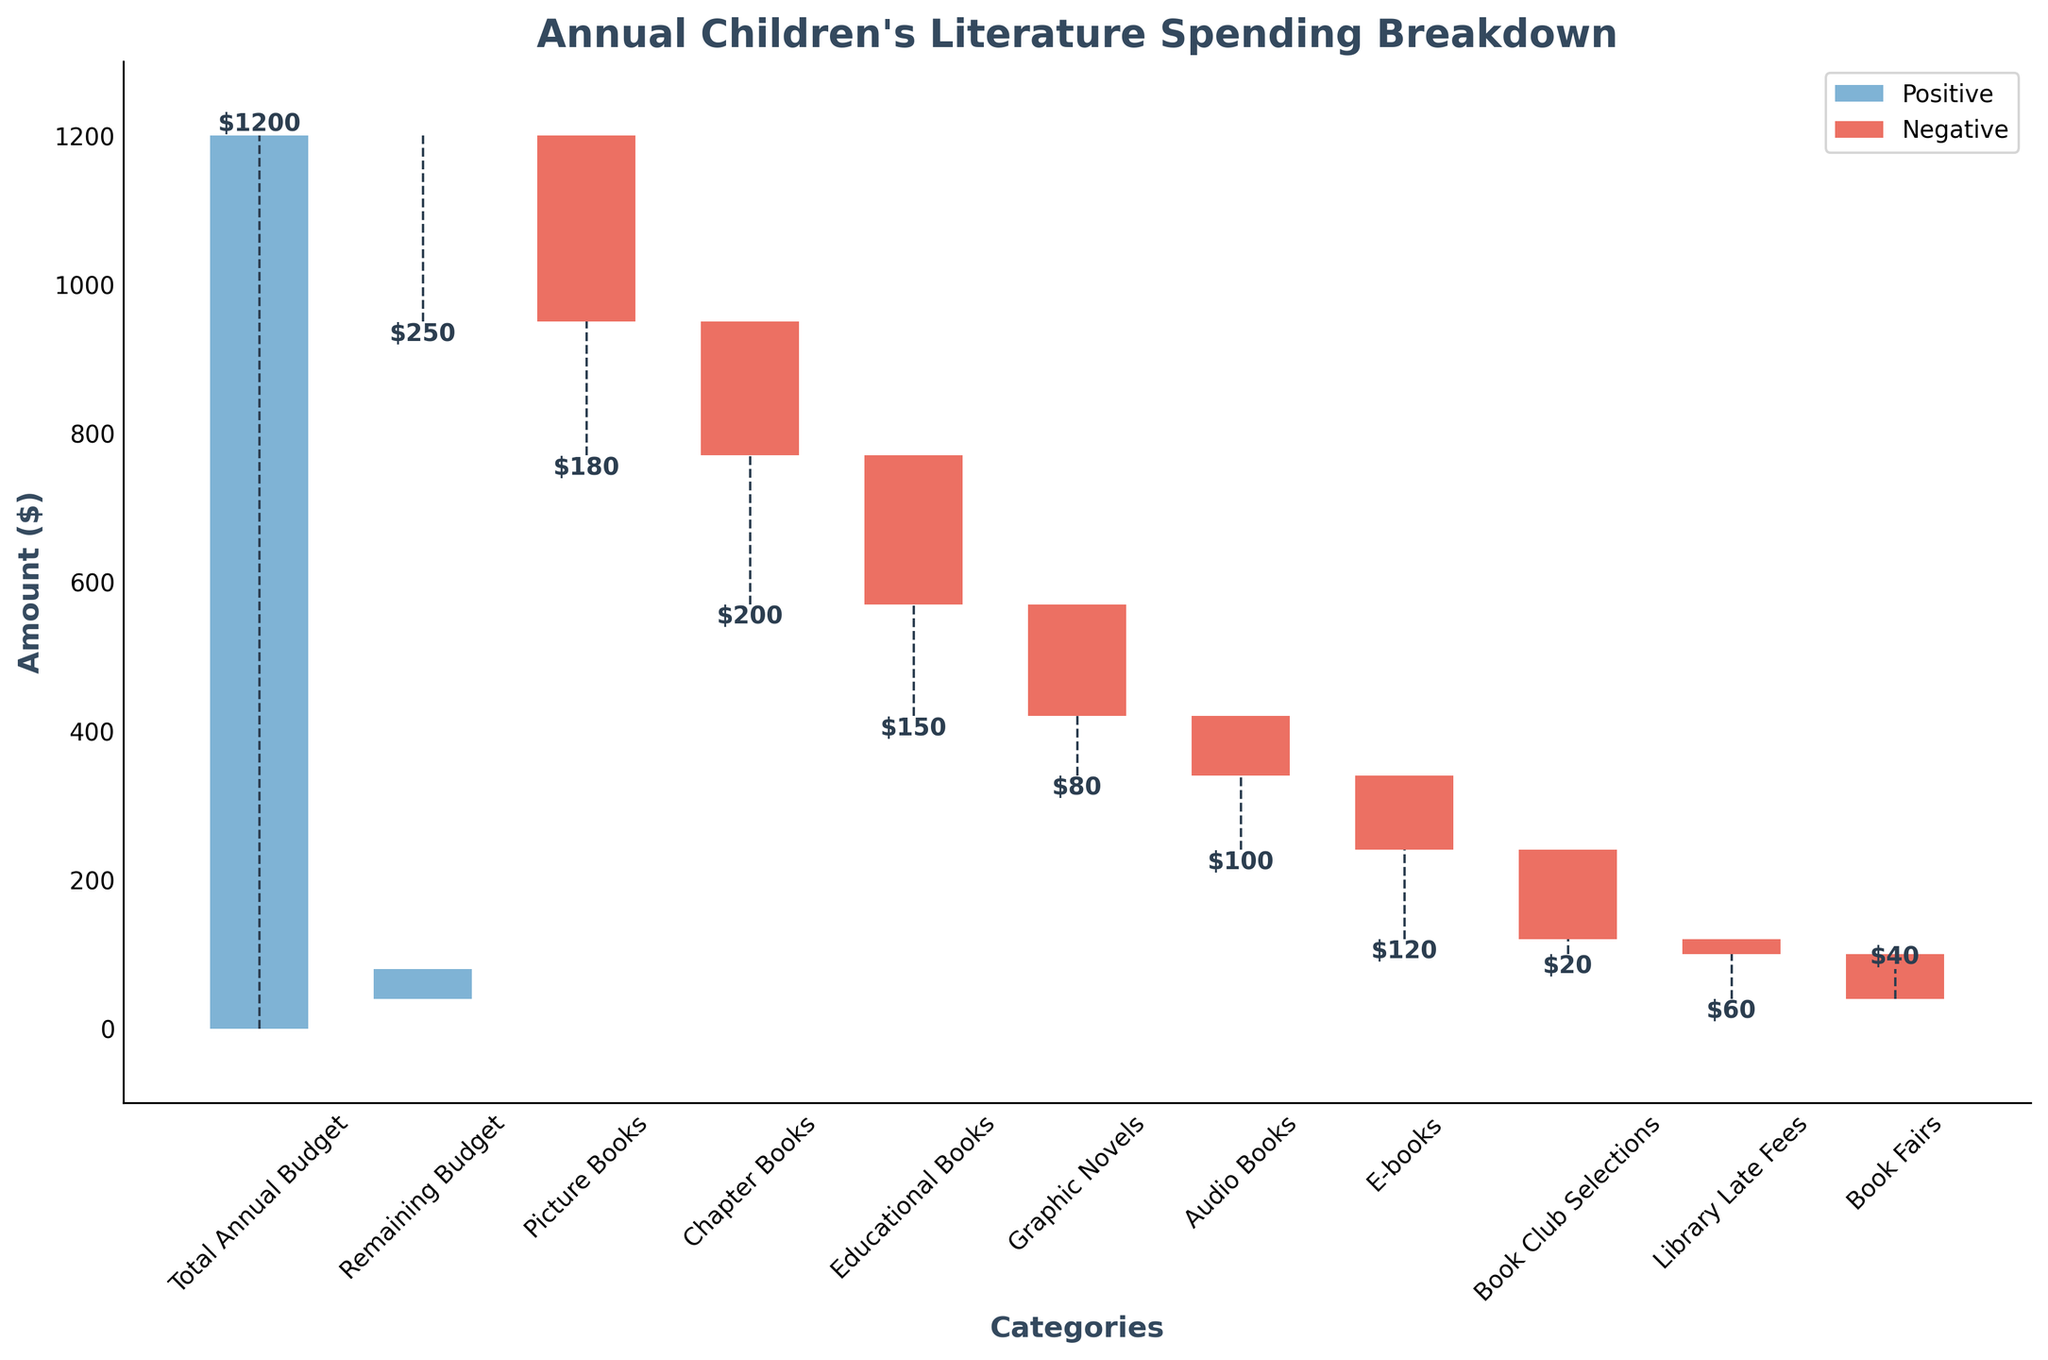What is the total annual budget for children's literature? The total annual budget is given in the data as the first category. It's the starting point of the waterfall chart.
Answer: $1200 How much is spent on picture books? The amount spent on picture books is represented by one of the negative bars labeled "Picture Books."
Answer: $250 What is the remaining budget after all spending categories have been accounted for? The remaining budget is the final positive category in the waterfall chart labeled "Remaining Budget."
Answer: $40 Which category has the smallest expenditure? The smallest expenditure can be found by looking for the smallest negative bar in the chart, which is labeled "Library Late Fees."
Answer: $20 How much is spent on book club selections? The expenditure on book club selections is represented by a negative bar labeled "Book Club Selections."
Answer: $120 What is the total expenditure on Chapter Books and Educational Books combined? To find the total expenditure on Chapter Books and Educational Books, sum their absolute values: $180 + $200 = $380.
Answer: $380 Which category has the largest expenditure, and how much is it? The largest expenditure can be found by identifying the largest negative bar, which is labeled "Picture Books."
Answer: $250 What is the difference in expenditure between Audio Books and E-books? The difference is calculated by subtracting the amount for Audio Books from that for E-books: $100 - $80 = $20.
Answer: $20 How much more is spent on Picture Books compared to Educational Books? Subtract the expenditure on Educational Books from that on Picture Books: $250 - $200 = $50.
Answer: $50 What would the remaining budget be if there were no spending on Book Fairs? To find the remaining budget without Book Fairs, add the expenditure on Book Fairs back to the remaining budget: $60 + $40 = $100.
Answer: $100 